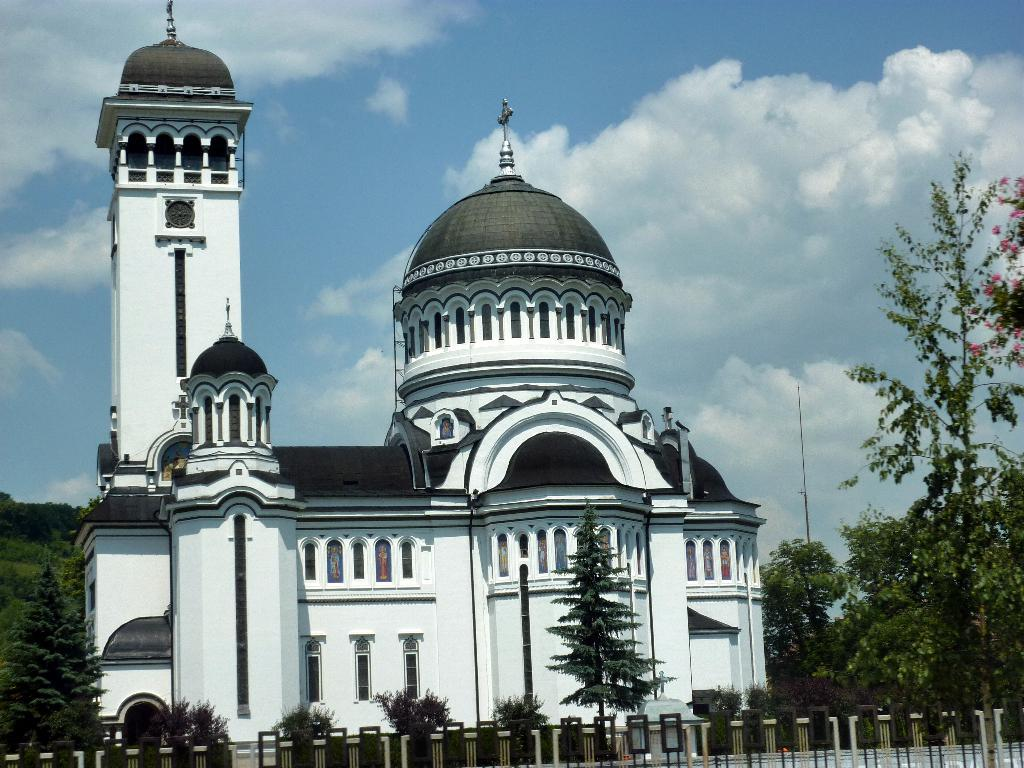What type of barrier can be seen in the image? There is a fence in the image. What type of natural elements are present in the image? There are trees and plants in the image. What type of structure is visible in the image? There is a building in the image. What is present in the background of the image? There is a pole and the sky visible in the background of the image. What can be seen in the sky in the image? Clouds are present in the sky. What type of income can be seen in the image? There is no reference to income in the image. Is there a doctor present in the image? There is no doctor present in the image. 